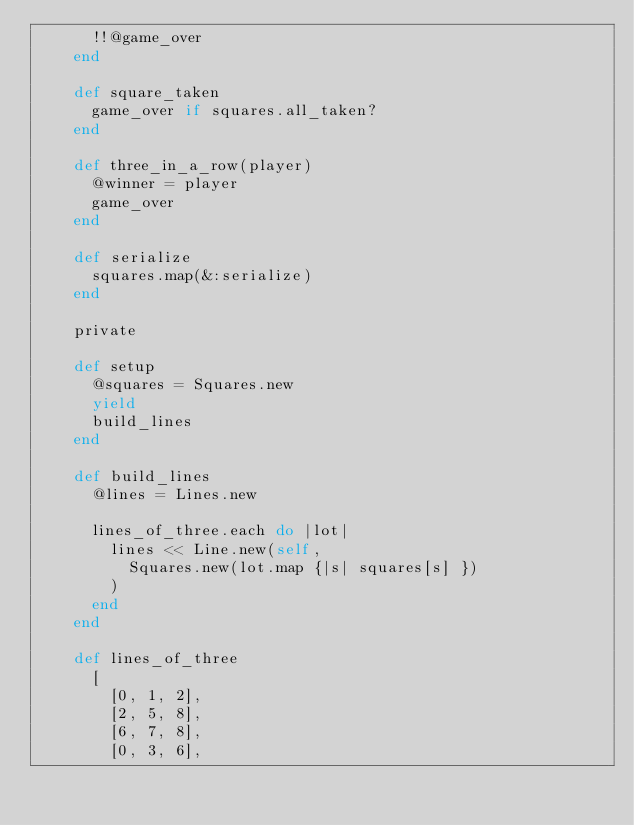<code> <loc_0><loc_0><loc_500><loc_500><_Ruby_>      !!@game_over
    end

    def square_taken
      game_over if squares.all_taken?
    end

    def three_in_a_row(player)
      @winner = player
      game_over
    end

    def serialize
      squares.map(&:serialize)
    end

    private

    def setup
      @squares = Squares.new
      yield
      build_lines
    end

    def build_lines
      @lines = Lines.new

      lines_of_three.each do |lot|
        lines << Line.new(self,
          Squares.new(lot.map {|s| squares[s] })
        )
      end
    end

    def lines_of_three
      [
        [0, 1, 2],
        [2, 5, 8],
        [6, 7, 8],
        [0, 3, 6],</code> 